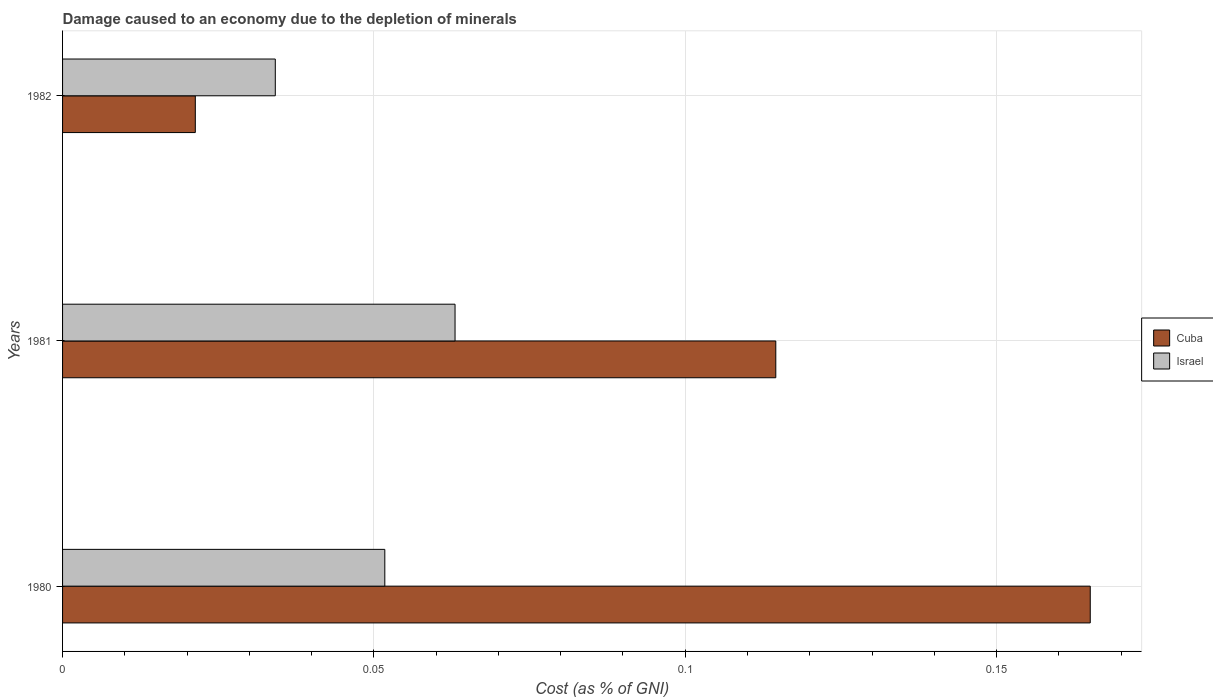Are the number of bars per tick equal to the number of legend labels?
Offer a terse response. Yes. Are the number of bars on each tick of the Y-axis equal?
Your answer should be very brief. Yes. How many bars are there on the 3rd tick from the bottom?
Offer a terse response. 2. What is the label of the 3rd group of bars from the top?
Give a very brief answer. 1980. What is the cost of damage caused due to the depletion of minerals in Cuba in 1982?
Offer a terse response. 0.02. Across all years, what is the maximum cost of damage caused due to the depletion of minerals in Israel?
Provide a short and direct response. 0.06. Across all years, what is the minimum cost of damage caused due to the depletion of minerals in Cuba?
Offer a very short reply. 0.02. What is the total cost of damage caused due to the depletion of minerals in Israel in the graph?
Ensure brevity in your answer.  0.15. What is the difference between the cost of damage caused due to the depletion of minerals in Israel in 1980 and that in 1981?
Keep it short and to the point. -0.01. What is the difference between the cost of damage caused due to the depletion of minerals in Cuba in 1980 and the cost of damage caused due to the depletion of minerals in Israel in 1982?
Your answer should be very brief. 0.13. What is the average cost of damage caused due to the depletion of minerals in Cuba per year?
Ensure brevity in your answer.  0.1. In the year 1981, what is the difference between the cost of damage caused due to the depletion of minerals in Cuba and cost of damage caused due to the depletion of minerals in Israel?
Offer a very short reply. 0.05. What is the ratio of the cost of damage caused due to the depletion of minerals in Israel in 1980 to that in 1981?
Offer a very short reply. 0.82. Is the difference between the cost of damage caused due to the depletion of minerals in Cuba in 1980 and 1981 greater than the difference between the cost of damage caused due to the depletion of minerals in Israel in 1980 and 1981?
Ensure brevity in your answer.  Yes. What is the difference between the highest and the second highest cost of damage caused due to the depletion of minerals in Israel?
Provide a succinct answer. 0.01. What is the difference between the highest and the lowest cost of damage caused due to the depletion of minerals in Israel?
Offer a terse response. 0.03. In how many years, is the cost of damage caused due to the depletion of minerals in Cuba greater than the average cost of damage caused due to the depletion of minerals in Cuba taken over all years?
Provide a short and direct response. 2. Is the sum of the cost of damage caused due to the depletion of minerals in Cuba in 1980 and 1982 greater than the maximum cost of damage caused due to the depletion of minerals in Israel across all years?
Your answer should be very brief. Yes. What does the 1st bar from the bottom in 1980 represents?
Your answer should be very brief. Cuba. How many bars are there?
Your answer should be compact. 6. Are the values on the major ticks of X-axis written in scientific E-notation?
Give a very brief answer. No. Does the graph contain any zero values?
Your answer should be compact. No. Does the graph contain grids?
Your answer should be compact. Yes. Where does the legend appear in the graph?
Provide a short and direct response. Center right. How many legend labels are there?
Ensure brevity in your answer.  2. How are the legend labels stacked?
Provide a short and direct response. Vertical. What is the title of the graph?
Your response must be concise. Damage caused to an economy due to the depletion of minerals. What is the label or title of the X-axis?
Offer a very short reply. Cost (as % of GNI). What is the Cost (as % of GNI) in Cuba in 1980?
Make the answer very short. 0.17. What is the Cost (as % of GNI) of Israel in 1980?
Ensure brevity in your answer.  0.05. What is the Cost (as % of GNI) in Cuba in 1981?
Provide a succinct answer. 0.11. What is the Cost (as % of GNI) in Israel in 1981?
Ensure brevity in your answer.  0.06. What is the Cost (as % of GNI) of Cuba in 1982?
Your response must be concise. 0.02. What is the Cost (as % of GNI) of Israel in 1982?
Ensure brevity in your answer.  0.03. Across all years, what is the maximum Cost (as % of GNI) in Cuba?
Ensure brevity in your answer.  0.17. Across all years, what is the maximum Cost (as % of GNI) of Israel?
Your answer should be very brief. 0.06. Across all years, what is the minimum Cost (as % of GNI) in Cuba?
Keep it short and to the point. 0.02. Across all years, what is the minimum Cost (as % of GNI) in Israel?
Your response must be concise. 0.03. What is the total Cost (as % of GNI) in Cuba in the graph?
Make the answer very short. 0.3. What is the total Cost (as % of GNI) of Israel in the graph?
Ensure brevity in your answer.  0.15. What is the difference between the Cost (as % of GNI) of Cuba in 1980 and that in 1981?
Ensure brevity in your answer.  0.05. What is the difference between the Cost (as % of GNI) of Israel in 1980 and that in 1981?
Provide a short and direct response. -0.01. What is the difference between the Cost (as % of GNI) in Cuba in 1980 and that in 1982?
Your answer should be compact. 0.14. What is the difference between the Cost (as % of GNI) of Israel in 1980 and that in 1982?
Provide a short and direct response. 0.02. What is the difference between the Cost (as % of GNI) of Cuba in 1981 and that in 1982?
Your answer should be very brief. 0.09. What is the difference between the Cost (as % of GNI) of Israel in 1981 and that in 1982?
Provide a succinct answer. 0.03. What is the difference between the Cost (as % of GNI) of Cuba in 1980 and the Cost (as % of GNI) of Israel in 1981?
Your answer should be compact. 0.1. What is the difference between the Cost (as % of GNI) of Cuba in 1980 and the Cost (as % of GNI) of Israel in 1982?
Give a very brief answer. 0.13. What is the difference between the Cost (as % of GNI) in Cuba in 1981 and the Cost (as % of GNI) in Israel in 1982?
Give a very brief answer. 0.08. What is the average Cost (as % of GNI) in Cuba per year?
Give a very brief answer. 0.1. What is the average Cost (as % of GNI) of Israel per year?
Provide a short and direct response. 0.05. In the year 1980, what is the difference between the Cost (as % of GNI) of Cuba and Cost (as % of GNI) of Israel?
Ensure brevity in your answer.  0.11. In the year 1981, what is the difference between the Cost (as % of GNI) in Cuba and Cost (as % of GNI) in Israel?
Give a very brief answer. 0.05. In the year 1982, what is the difference between the Cost (as % of GNI) in Cuba and Cost (as % of GNI) in Israel?
Offer a terse response. -0.01. What is the ratio of the Cost (as % of GNI) of Cuba in 1980 to that in 1981?
Provide a short and direct response. 1.44. What is the ratio of the Cost (as % of GNI) in Israel in 1980 to that in 1981?
Your answer should be compact. 0.82. What is the ratio of the Cost (as % of GNI) in Cuba in 1980 to that in 1982?
Provide a succinct answer. 7.74. What is the ratio of the Cost (as % of GNI) of Israel in 1980 to that in 1982?
Keep it short and to the point. 1.51. What is the ratio of the Cost (as % of GNI) of Cuba in 1981 to that in 1982?
Keep it short and to the point. 5.37. What is the ratio of the Cost (as % of GNI) in Israel in 1981 to that in 1982?
Your answer should be compact. 1.84. What is the difference between the highest and the second highest Cost (as % of GNI) in Cuba?
Offer a terse response. 0.05. What is the difference between the highest and the second highest Cost (as % of GNI) of Israel?
Provide a succinct answer. 0.01. What is the difference between the highest and the lowest Cost (as % of GNI) in Cuba?
Keep it short and to the point. 0.14. What is the difference between the highest and the lowest Cost (as % of GNI) of Israel?
Make the answer very short. 0.03. 